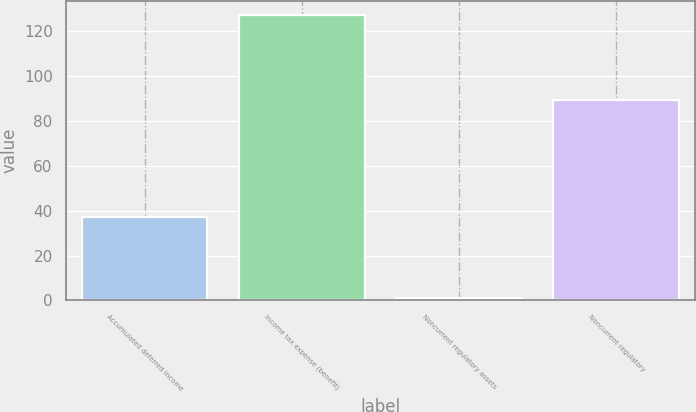Convert chart to OTSL. <chart><loc_0><loc_0><loc_500><loc_500><bar_chart><fcel>Accumulated deferred income<fcel>Income tax expense (benefit)<fcel>Noncurrent regulatory assets<fcel>Noncurrent regulatory<nl><fcel>37<fcel>127<fcel>1<fcel>89<nl></chart> 